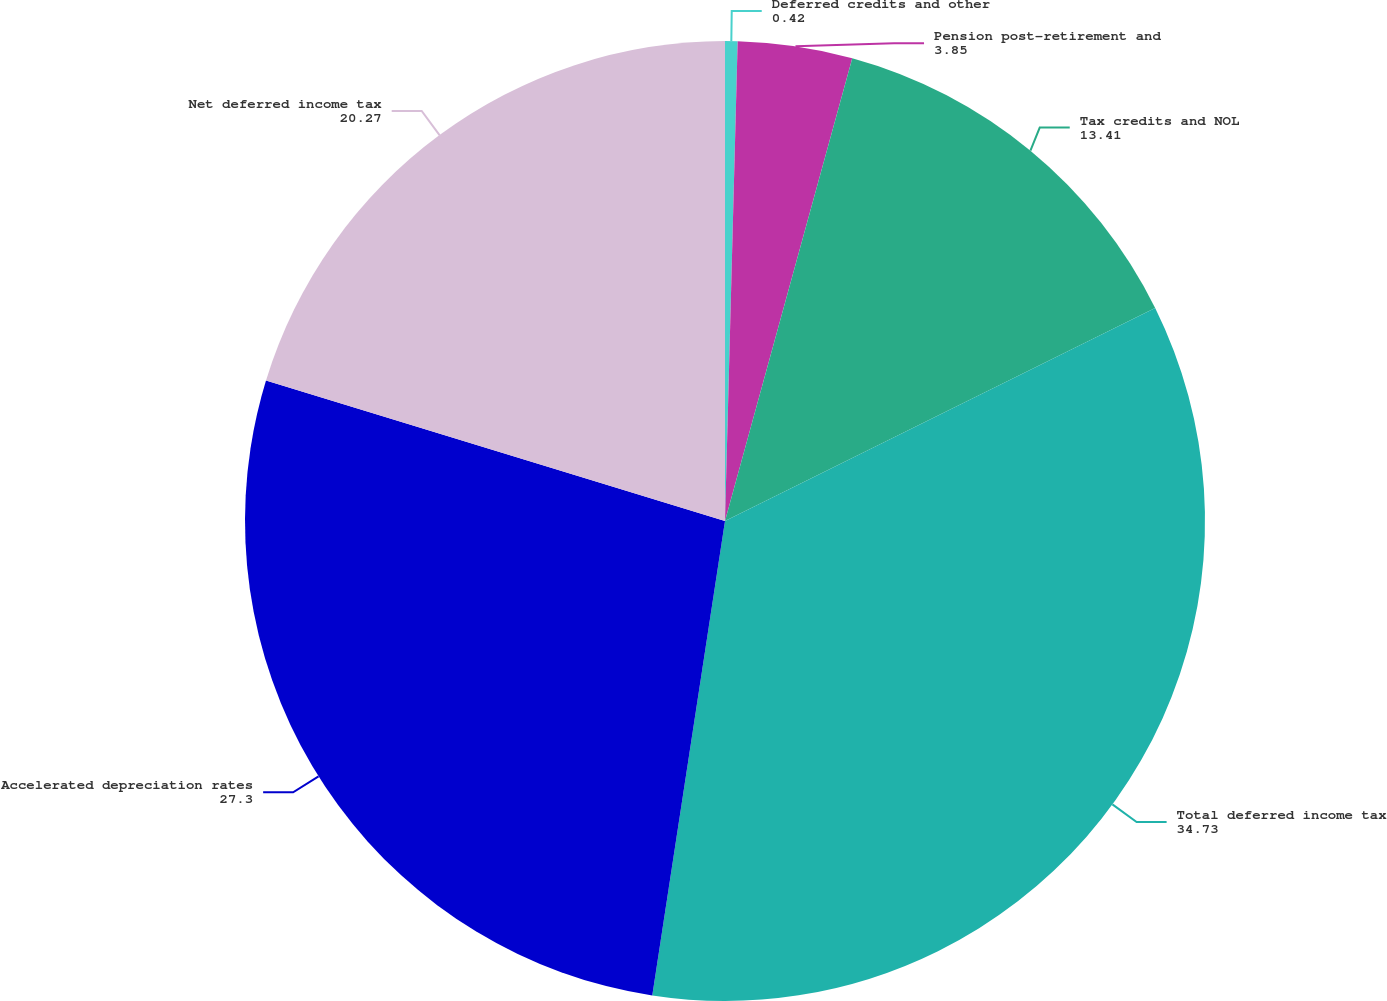<chart> <loc_0><loc_0><loc_500><loc_500><pie_chart><fcel>Deferred credits and other<fcel>Pension post-retirement and<fcel>Tax credits and NOL<fcel>Total deferred income tax<fcel>Accelerated depreciation rates<fcel>Net deferred income tax<nl><fcel>0.42%<fcel>3.85%<fcel>13.41%<fcel>34.73%<fcel>27.3%<fcel>20.27%<nl></chart> 